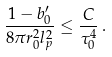Convert formula to latex. <formula><loc_0><loc_0><loc_500><loc_500>\frac { 1 - b _ { 0 } ^ { \prime } } { 8 \pi r _ { 0 } ^ { 2 } l _ { p } ^ { 2 } } \leq \frac { C } { \tau _ { 0 } ^ { 4 } } \, .</formula> 